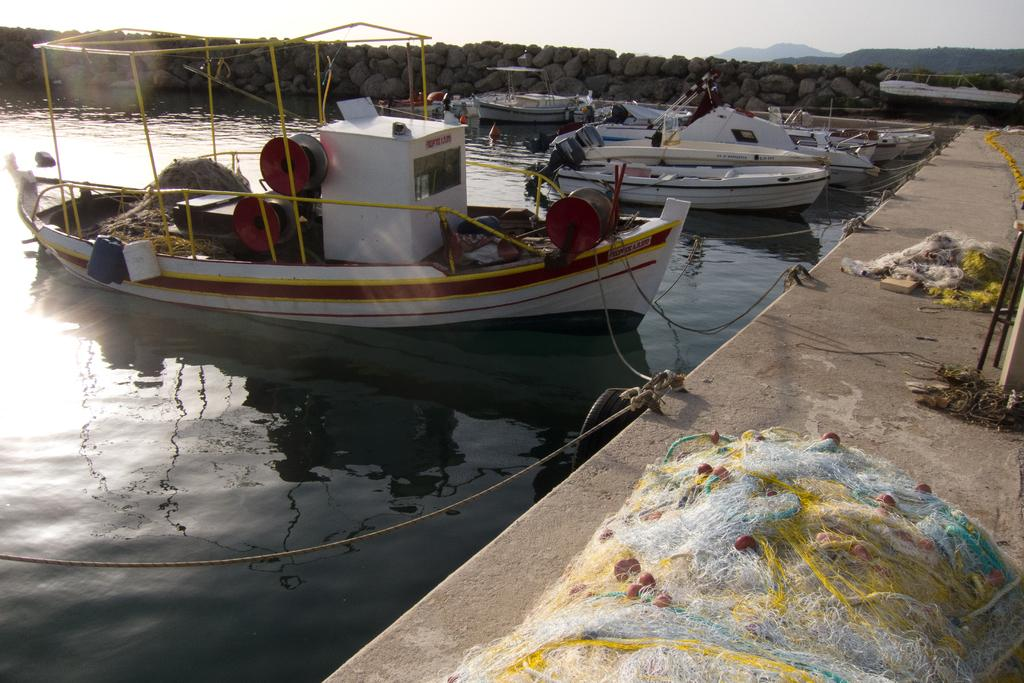What is in the water in the image? There are boats in the water in the image. What can be seen on the right side of the image? There is a platform on the right side of the image. What is on the platform? Nets are present on the platform. What can be seen in the background of the image? There are stones visible in the background of the image. Is there smoke coming from the boats in the image? There is no smoke present in the image; it only shows boats in the water. How many snakes can be seen on the platform in the image? There are no snakes present in the image; it only shows nets on the platform. 